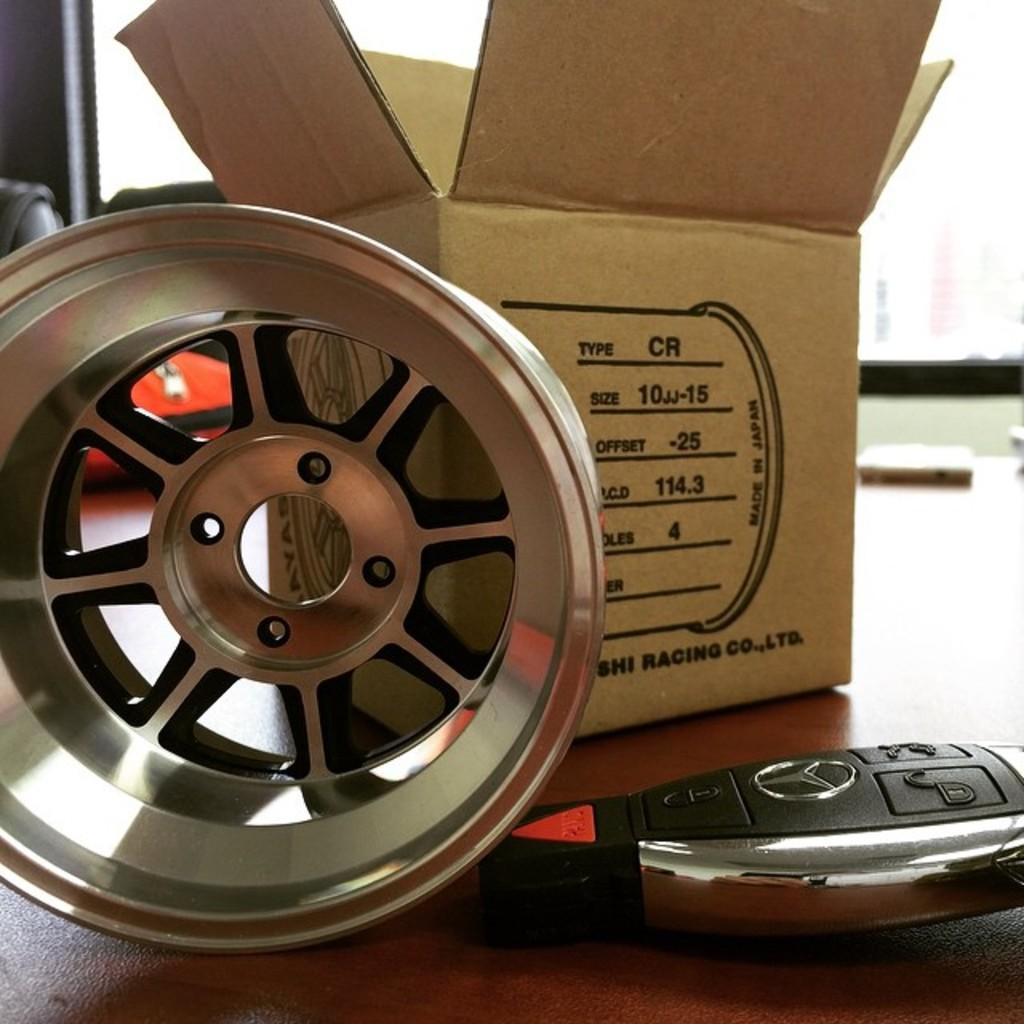Please provide a concise description of this image. In this picture we can see a box, rim and a car smart key on the platform. Background portion of the picture is blurred. We can see objects. 